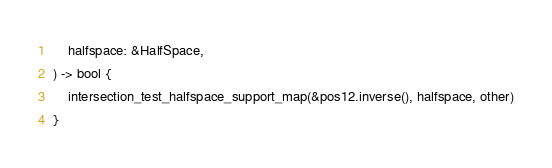<code> <loc_0><loc_0><loc_500><loc_500><_Rust_>    halfspace: &HalfSpace,
) -> bool {
    intersection_test_halfspace_support_map(&pos12.inverse(), halfspace, other)
}
</code> 